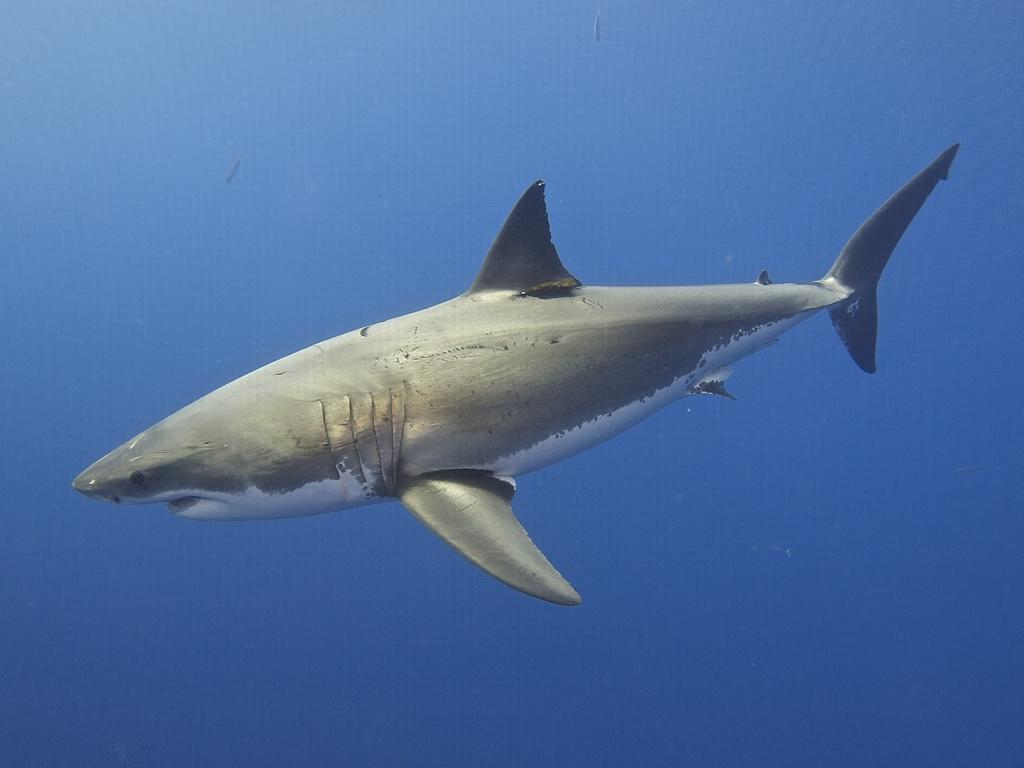What is the main subject of the image? There is a shark in the middle of the image. Can you describe the shark's position in the image? The shark is located in the middle of the image. What type of coal is being used by the shark to power its way through the water in the image? There is the shark's actions or behavior in the image, and there is no mention of coal or any other power source. The shark is simply swimming in the water. 